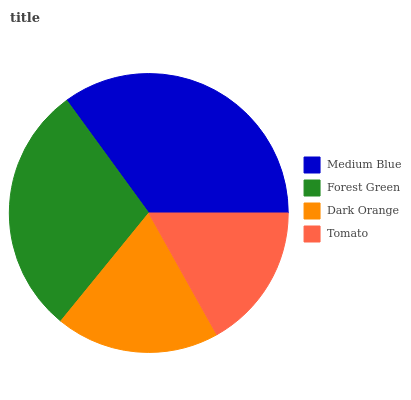Is Tomato the minimum?
Answer yes or no. Yes. Is Medium Blue the maximum?
Answer yes or no. Yes. Is Forest Green the minimum?
Answer yes or no. No. Is Forest Green the maximum?
Answer yes or no. No. Is Medium Blue greater than Forest Green?
Answer yes or no. Yes. Is Forest Green less than Medium Blue?
Answer yes or no. Yes. Is Forest Green greater than Medium Blue?
Answer yes or no. No. Is Medium Blue less than Forest Green?
Answer yes or no. No. Is Forest Green the high median?
Answer yes or no. Yes. Is Dark Orange the low median?
Answer yes or no. Yes. Is Tomato the high median?
Answer yes or no. No. Is Medium Blue the low median?
Answer yes or no. No. 